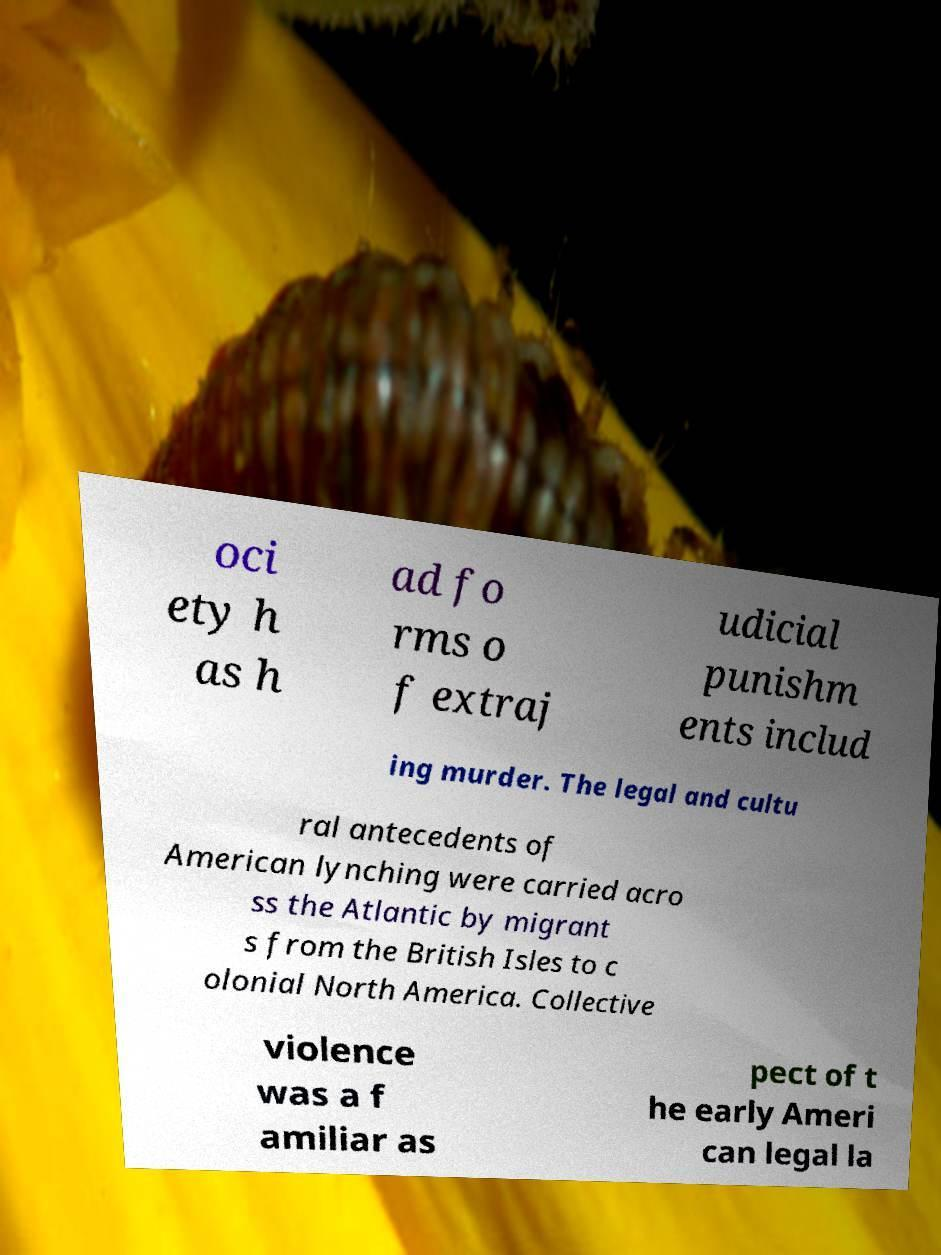What messages or text are displayed in this image? I need them in a readable, typed format. oci ety h as h ad fo rms o f extraj udicial punishm ents includ ing murder. The legal and cultu ral antecedents of American lynching were carried acro ss the Atlantic by migrant s from the British Isles to c olonial North America. Collective violence was a f amiliar as pect of t he early Ameri can legal la 